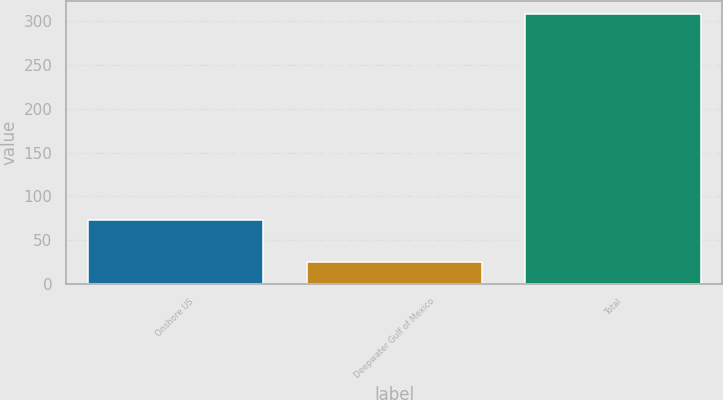Convert chart. <chart><loc_0><loc_0><loc_500><loc_500><bar_chart><fcel>Onshore US<fcel>Deepwater Gulf of Mexico<fcel>Total<nl><fcel>73<fcel>25<fcel>308<nl></chart> 